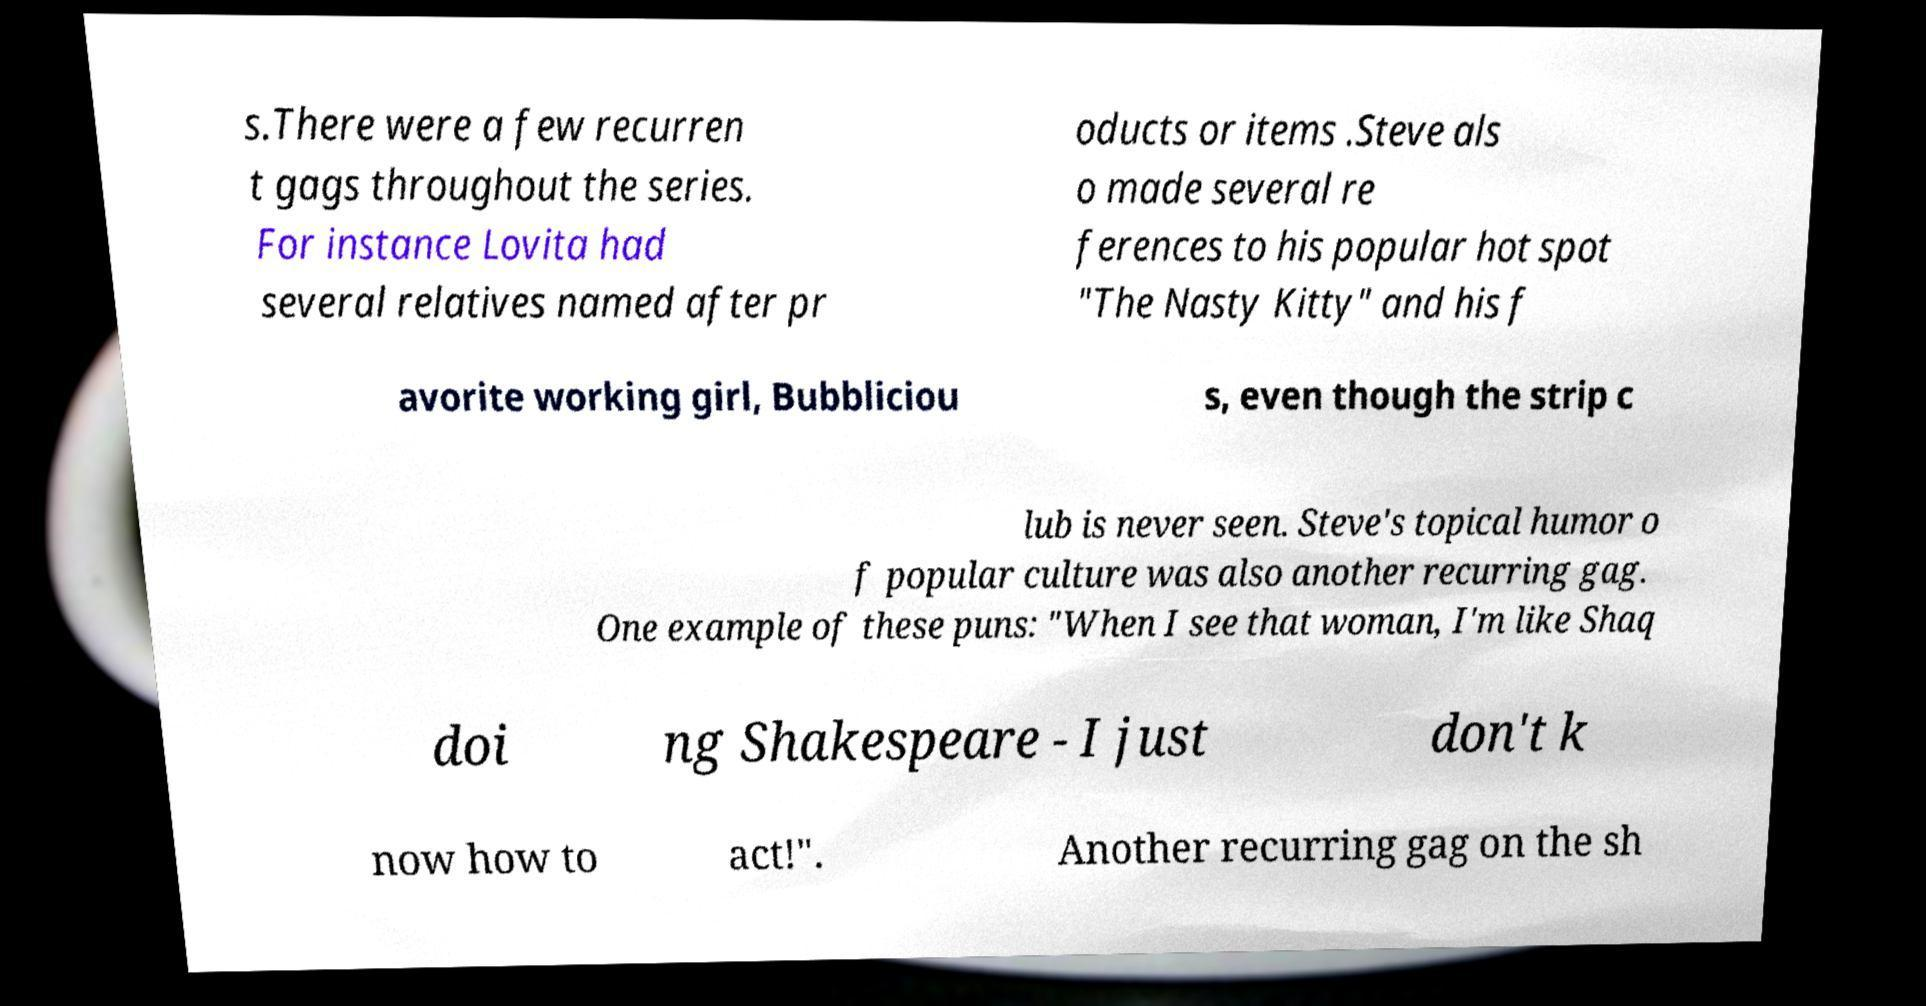Please read and relay the text visible in this image. What does it say? s.There were a few recurren t gags throughout the series. For instance Lovita had several relatives named after pr oducts or items .Steve als o made several re ferences to his popular hot spot "The Nasty Kitty" and his f avorite working girl, Bubbliciou s, even though the strip c lub is never seen. Steve's topical humor o f popular culture was also another recurring gag. One example of these puns: "When I see that woman, I'm like Shaq doi ng Shakespeare - I just don't k now how to act!". Another recurring gag on the sh 